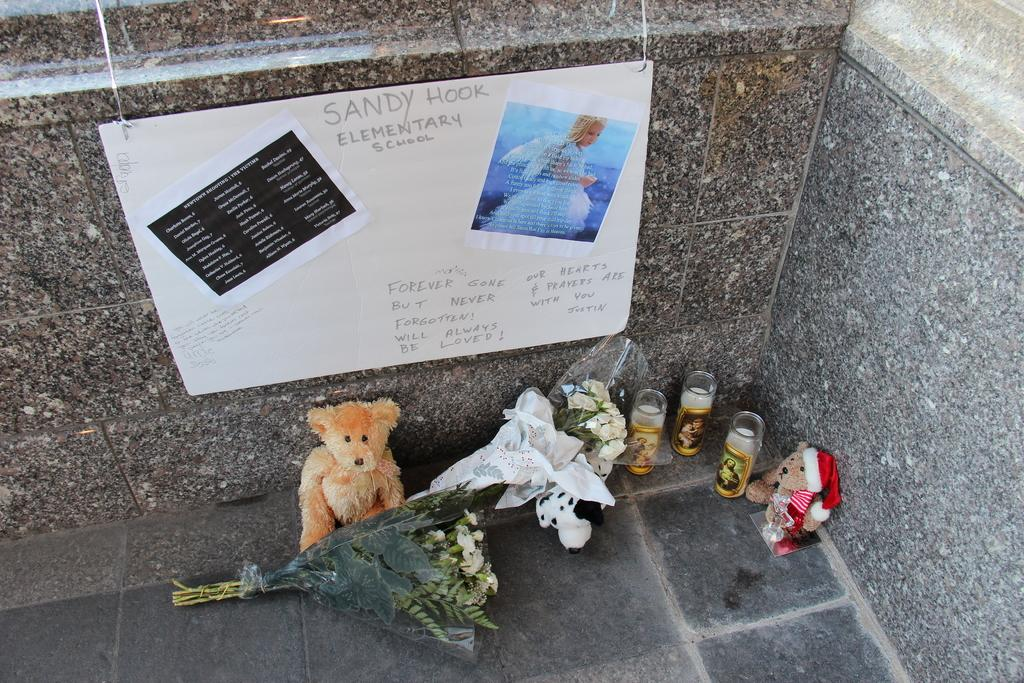How many dolls are present in the image? There are two dolls in the image. What else can be seen in the image besides the dolls? There is a bouquet in the image, along with other unspecified things around the dolls and bouquet. Can you describe the background of the image? There is a poster on a wall in the image. How does the dirt affect the dolls in the image? There is no dirt present in the image, so it does not affect the dolls. 